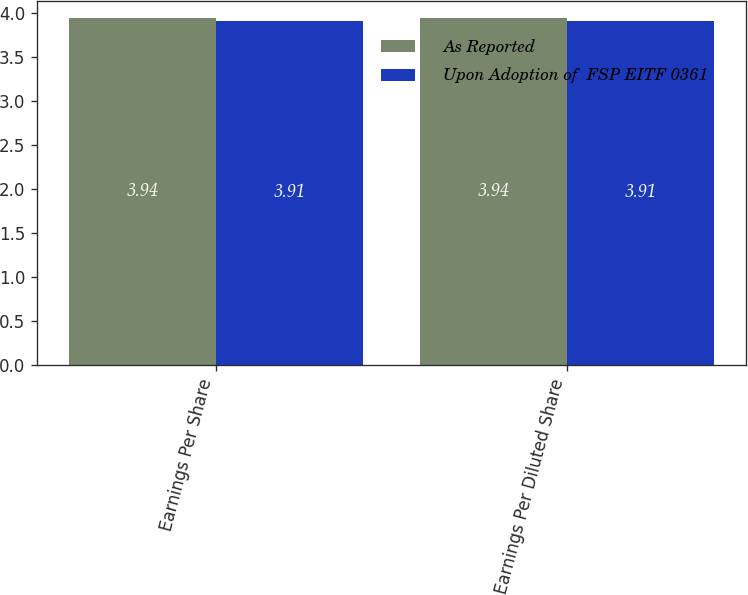Convert chart to OTSL. <chart><loc_0><loc_0><loc_500><loc_500><stacked_bar_chart><ecel><fcel>Earnings Per Share<fcel>Earnings Per Diluted Share<nl><fcel>As Reported<fcel>3.94<fcel>3.94<nl><fcel>Upon Adoption of  FSP EITF 0361<fcel>3.91<fcel>3.91<nl></chart> 